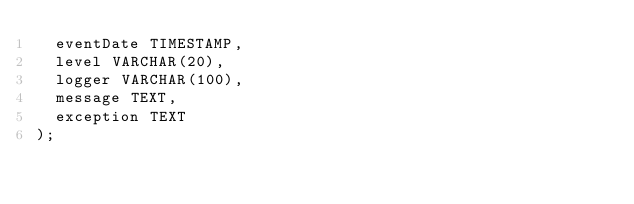<code> <loc_0><loc_0><loc_500><loc_500><_SQL_>  eventDate TIMESTAMP,
  level VARCHAR(20),
  logger VARCHAR(100),
  message TEXT,
  exception TEXT
);
</code> 